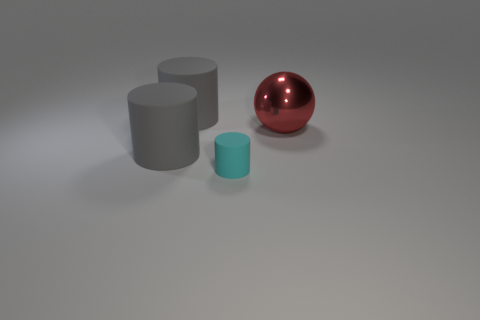Add 3 small brown cubes. How many objects exist? 7 Subtract all big cylinders. How many cylinders are left? 1 Subtract all cyan cylinders. How many cylinders are left? 2 Subtract all cylinders. How many objects are left? 1 Subtract 1 cylinders. How many cylinders are left? 2 Add 4 metallic things. How many metallic things exist? 5 Subtract 0 purple cubes. How many objects are left? 4 Subtract all cyan balls. Subtract all cyan cubes. How many balls are left? 1 Subtract all yellow blocks. How many cyan cylinders are left? 1 Subtract all green cylinders. Subtract all large red shiny things. How many objects are left? 3 